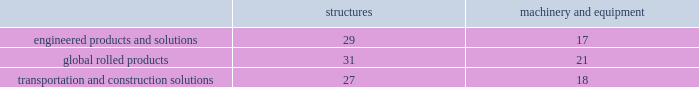Arconic and subsidiaries notes to the consolidated financial statements ( dollars in millions , except per-share amounts ) a .
Summary of significant accounting policies basis of presentation .
The consolidated financial statements of arconic inc .
And subsidiaries ( 201carconic 201d or the 201ccompany 201d ) are prepared in conformity with accounting principles generally accepted in the united states of america ( gaap ) and require management to make certain judgments , estimates , and assumptions .
These may affect the reported amounts of assets and liabilities and the disclosure of contingent assets and liabilities at the date of the financial statements .
They also may affect the reported amounts of revenues and expenses during the reporting period .
Actual results could differ from those estimates upon subsequent resolution of identified matters .
Certain amounts in previously issued financial statements were reclassified to conform to the current period presentation ( see below and note c ) on january 1 , 2018 , arconic adopted new guidance issued by the financial accounting standards board ( fasb ) related to the following : presentation of net periodic pension cost and net periodic postretirement benefit cost that required a reclassification of costs within the statement of consolidated operations ; presentation of certain cash receipts and cash payments within the statement of consolidated cash flows that required a reclassification of amounts between operating and either financing or investing activities ; the classification of restricted cash within the statement of consolidated cash flows ; and the reclassification from accumulated other comprehensive loss to accumulated deficit in the consolidated balance sheet of stranded tax effects resulting from the tax cuts and jobs act enacted on december 22 , 2017 .
See recently adopted accounting guidance below for further details .
Also on january 1 , 2018 , the company changed its primary measure of segment performance from adjusted earnings before interest , tax , depreciation and amortization ( 201cadjusted ebitda 201d ) to segment operating profit , which more closely aligns segment performance with operating income as presented in the statement of consolidated operations .
See note c for further details .
The separation of alcoa inc .
Into two standalone , publicly-traded companies , arconic inc .
( the new name for alcoa inc. ) and alcoa corporation , became effective on november 1 , 2016 ( the 201cseparation transaction 201d ) .
The financial results of alcoa corporation for 2016 have been retrospectively reflected in the statement of consolidated operations as discontinued operations and , as such , have been excluded from continuing operations and segment results for 2016 .
The cash flows and comprehensive income related to alcoa corporation have not been segregated and are included in the statement of consolidated cash flows and statement of consolidated comprehensive income ( loss ) , respectively , for 2016 .
See note v for additional information related to the separation transaction and discontinued operations .
Principles of consolidation .
The consolidated financial statements include the accounts of arconic and companies in which arconic has a controlling interest .
Intercompany transactions have been eliminated .
Investments in affiliates in which arconic cannot exercise significant influence are accounted for on the cost method .
Management also evaluates whether an arconic entity or interest is a variable interest entity and whether arconic is the primary beneficiary .
Consolidation is required if both of these criteria are met .
Arconic does not have any variable interest entities requiring consolidation .
Cash equivalents .
Cash equivalents are highly liquid investments purchased with an original maturity of three months or less .
Inventory valuation .
Inventories are carried at the lower of cost and net realizable value , with cost for approximately half of u.s .
Inventories determined under the last-in , first-out ( lifo ) method .
The cost of other inventories is determined under a combination of the first-in , first-out ( fifo ) and average-cost methods .
Properties , plants , and equipment .
Properties , plants , and equipment are recorded at cost .
Depreciation is recorded principally on the straight-line method at rates based on the estimated useful lives of the assets .
The table details the weighted-average useful lives of structures and machinery and equipment by reporting segment ( numbers in years ) : .
Gains or losses from the sale of asset groups are generally recorded in restructuring and other charges while the sale of individual assets are recorded in other expense ( income ) , net ( see policy below for assets classified as held for sale and discontinued operations ) .
Repairs and maintenance are charged to expense as incurred .
Interest related to the construction of qualifying assets is capitalized as part of the construction costs. .
What is the difference between the weighted average useful lives of structures and machinery/equipment in the global rolled products segment , in years? 
Rationale: it is the difference between the number of years .
Computations: (31 - 21)
Answer: 10.0. 